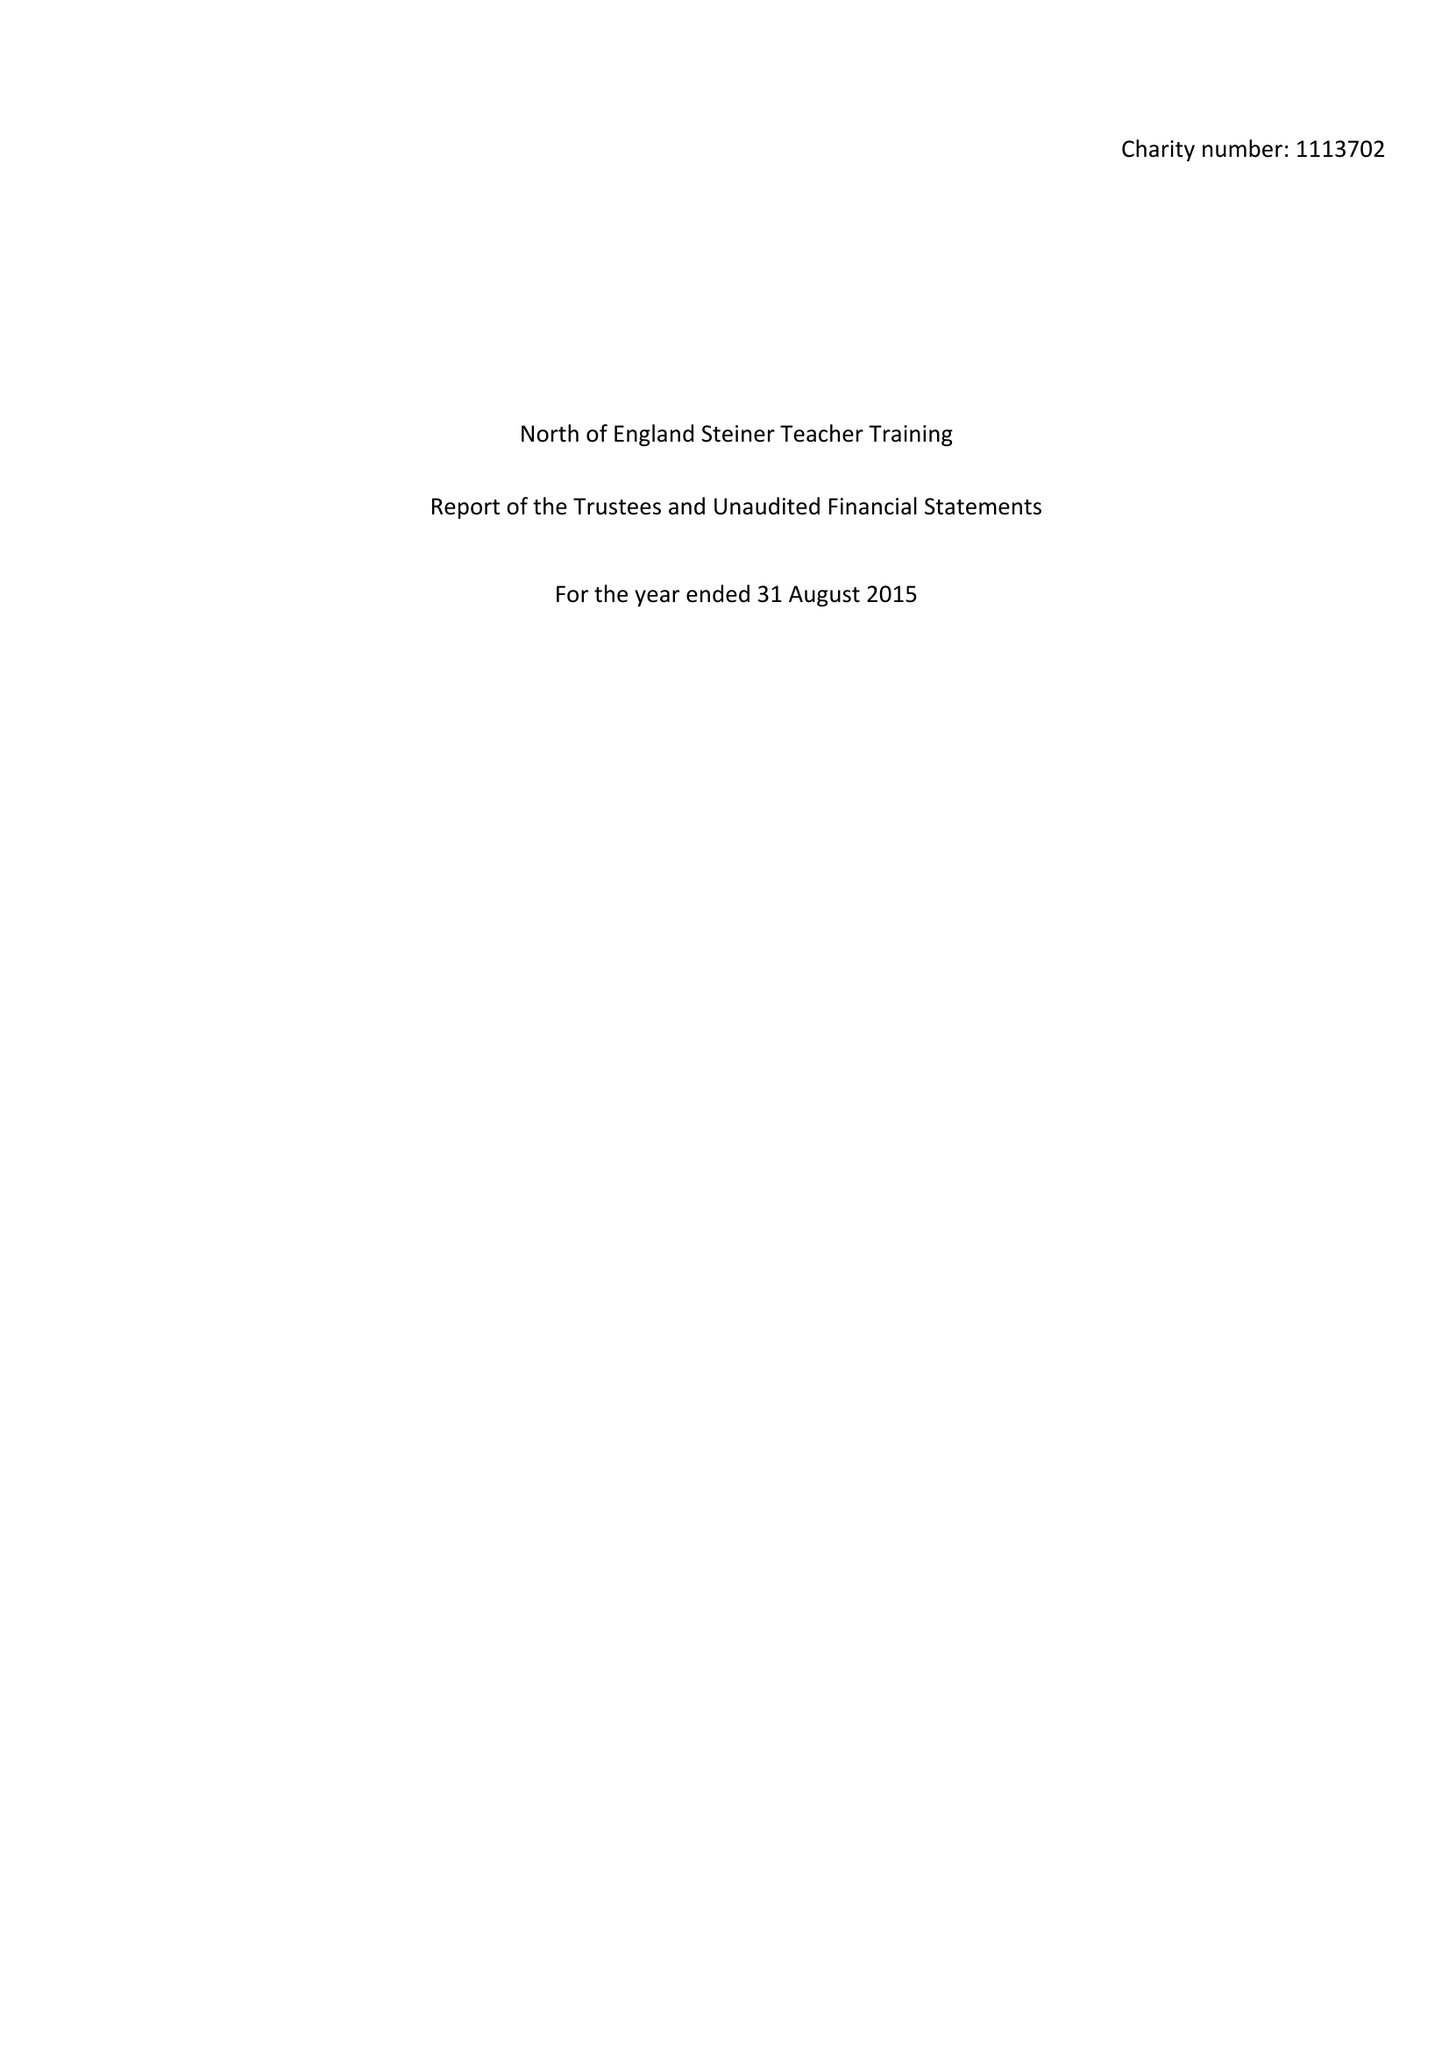What is the value for the address__postcode?
Answer the question using a single word or phrase. YO23 2RE 